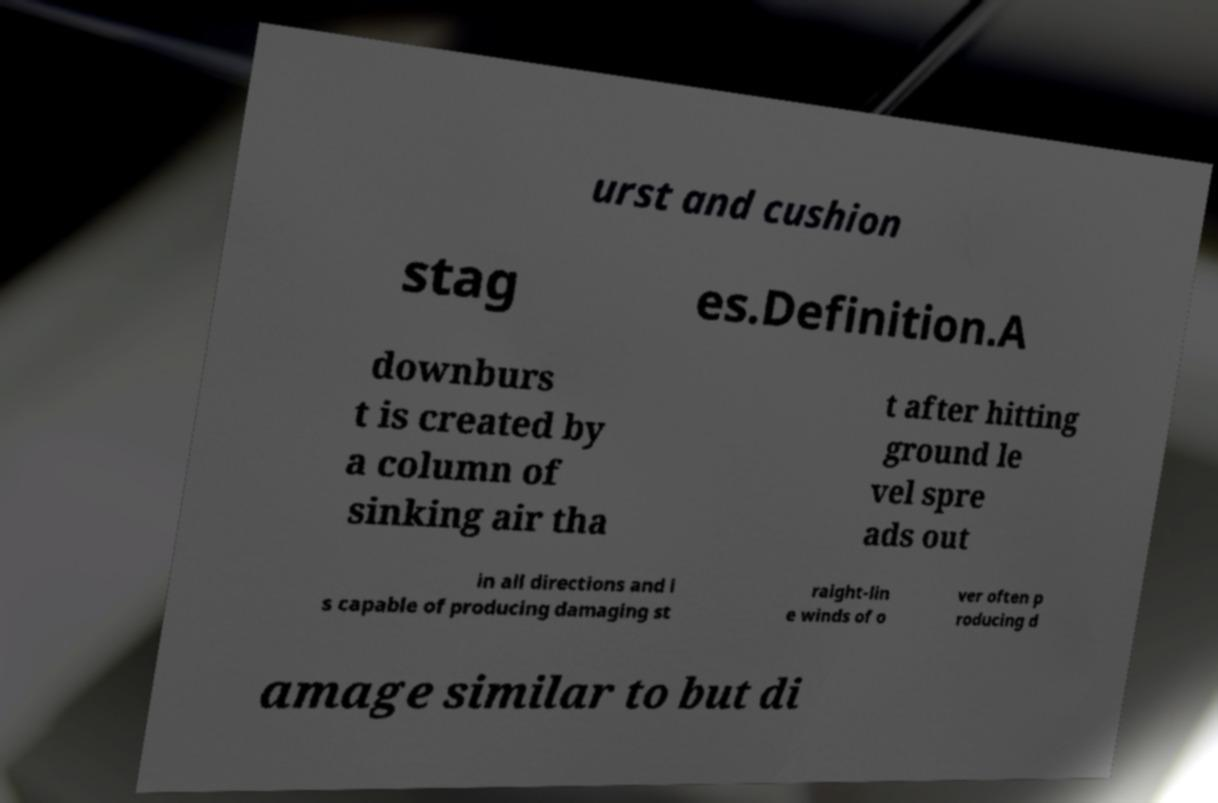Can you read and provide the text displayed in the image?This photo seems to have some interesting text. Can you extract and type it out for me? urst and cushion stag es.Definition.A downburs t is created by a column of sinking air tha t after hitting ground le vel spre ads out in all directions and i s capable of producing damaging st raight-lin e winds of o ver often p roducing d amage similar to but di 